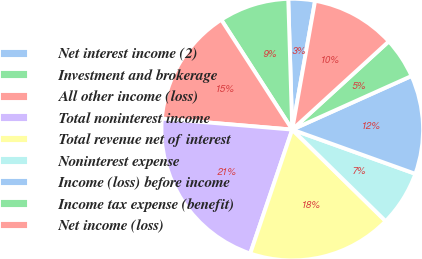Convert chart to OTSL. <chart><loc_0><loc_0><loc_500><loc_500><pie_chart><fcel>Net interest income (2)<fcel>Investment and brokerage<fcel>All other income (loss)<fcel>Total noninterest income<fcel>Total revenue net of interest<fcel>Noninterest expense<fcel>Income (loss) before income<fcel>Income tax expense (benefit)<fcel>Net income (loss)<nl><fcel>3.28%<fcel>8.64%<fcel>14.53%<fcel>21.14%<fcel>17.86%<fcel>6.85%<fcel>12.21%<fcel>5.06%<fcel>10.42%<nl></chart> 